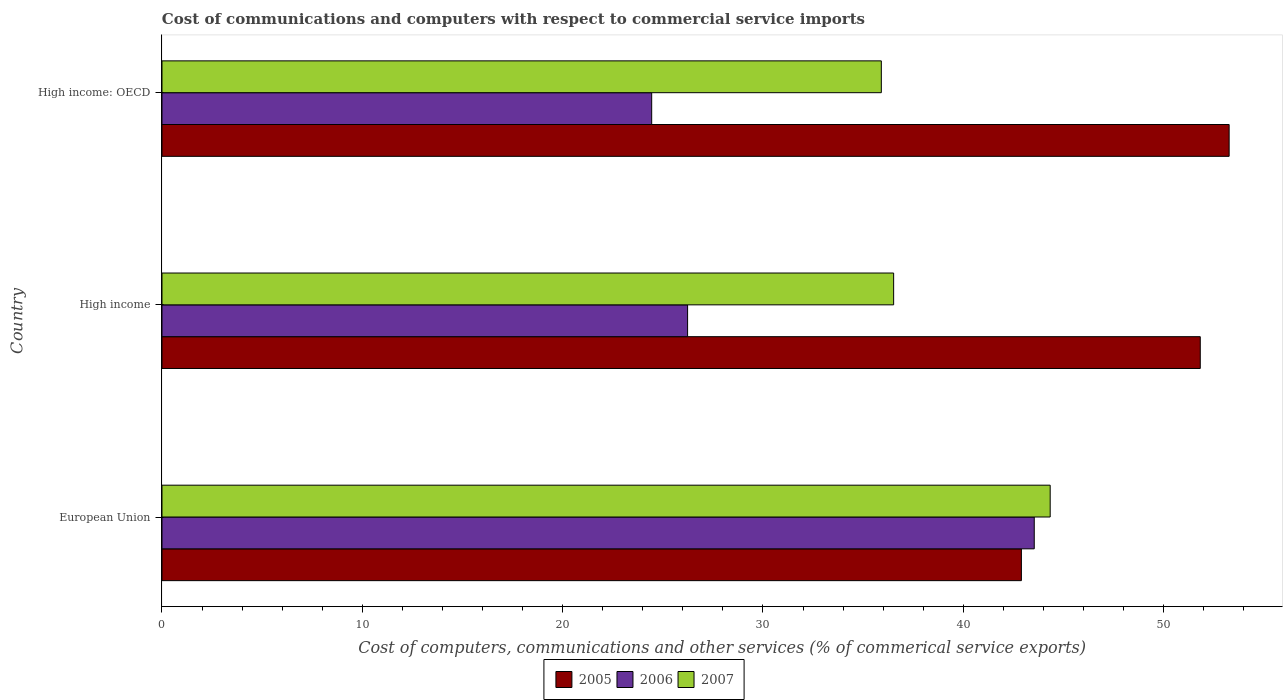How many different coloured bars are there?
Ensure brevity in your answer.  3. How many groups of bars are there?
Keep it short and to the point. 3. Are the number of bars on each tick of the Y-axis equal?
Ensure brevity in your answer.  Yes. What is the label of the 3rd group of bars from the top?
Offer a terse response. European Union. What is the cost of communications and computers in 2005 in European Union?
Offer a very short reply. 42.9. Across all countries, what is the maximum cost of communications and computers in 2007?
Your answer should be compact. 44.34. Across all countries, what is the minimum cost of communications and computers in 2005?
Your answer should be very brief. 42.9. In which country was the cost of communications and computers in 2005 minimum?
Provide a short and direct response. European Union. What is the total cost of communications and computers in 2007 in the graph?
Keep it short and to the point. 116.77. What is the difference between the cost of communications and computers in 2005 in European Union and that in High income?
Keep it short and to the point. -8.93. What is the difference between the cost of communications and computers in 2007 in European Union and the cost of communications and computers in 2005 in High income?
Give a very brief answer. -7.49. What is the average cost of communications and computers in 2006 per country?
Offer a terse response. 31.41. What is the difference between the cost of communications and computers in 2007 and cost of communications and computers in 2006 in High income: OECD?
Offer a terse response. 11.46. What is the ratio of the cost of communications and computers in 2005 in European Union to that in High income: OECD?
Offer a terse response. 0.81. What is the difference between the highest and the second highest cost of communications and computers in 2006?
Offer a terse response. 17.3. What is the difference between the highest and the lowest cost of communications and computers in 2006?
Your answer should be compact. 19.1. In how many countries, is the cost of communications and computers in 2005 greater than the average cost of communications and computers in 2005 taken over all countries?
Your response must be concise. 2. Is it the case that in every country, the sum of the cost of communications and computers in 2005 and cost of communications and computers in 2006 is greater than the cost of communications and computers in 2007?
Give a very brief answer. Yes. How many bars are there?
Your answer should be very brief. 9. How many countries are there in the graph?
Keep it short and to the point. 3. What is the difference between two consecutive major ticks on the X-axis?
Your answer should be compact. 10. Does the graph contain grids?
Make the answer very short. No. Where does the legend appear in the graph?
Provide a short and direct response. Bottom center. What is the title of the graph?
Provide a short and direct response. Cost of communications and computers with respect to commercial service imports. Does "1961" appear as one of the legend labels in the graph?
Provide a succinct answer. No. What is the label or title of the X-axis?
Your answer should be very brief. Cost of computers, communications and other services (% of commerical service exports). What is the Cost of computers, communications and other services (% of commerical service exports) in 2005 in European Union?
Offer a terse response. 42.9. What is the Cost of computers, communications and other services (% of commerical service exports) of 2006 in European Union?
Your answer should be compact. 43.54. What is the Cost of computers, communications and other services (% of commerical service exports) of 2007 in European Union?
Provide a succinct answer. 44.34. What is the Cost of computers, communications and other services (% of commerical service exports) of 2005 in High income?
Your response must be concise. 51.83. What is the Cost of computers, communications and other services (% of commerical service exports) in 2006 in High income?
Make the answer very short. 26.24. What is the Cost of computers, communications and other services (% of commerical service exports) in 2007 in High income?
Your answer should be very brief. 36.52. What is the Cost of computers, communications and other services (% of commerical service exports) of 2005 in High income: OECD?
Provide a short and direct response. 53.27. What is the Cost of computers, communications and other services (% of commerical service exports) in 2006 in High income: OECD?
Make the answer very short. 24.45. What is the Cost of computers, communications and other services (% of commerical service exports) of 2007 in High income: OECD?
Provide a short and direct response. 35.91. Across all countries, what is the maximum Cost of computers, communications and other services (% of commerical service exports) in 2005?
Give a very brief answer. 53.27. Across all countries, what is the maximum Cost of computers, communications and other services (% of commerical service exports) of 2006?
Provide a succinct answer. 43.54. Across all countries, what is the maximum Cost of computers, communications and other services (% of commerical service exports) in 2007?
Provide a short and direct response. 44.34. Across all countries, what is the minimum Cost of computers, communications and other services (% of commerical service exports) in 2005?
Give a very brief answer. 42.9. Across all countries, what is the minimum Cost of computers, communications and other services (% of commerical service exports) in 2006?
Provide a succinct answer. 24.45. Across all countries, what is the minimum Cost of computers, communications and other services (% of commerical service exports) of 2007?
Provide a succinct answer. 35.91. What is the total Cost of computers, communications and other services (% of commerical service exports) of 2005 in the graph?
Your response must be concise. 148. What is the total Cost of computers, communications and other services (% of commerical service exports) of 2006 in the graph?
Make the answer very short. 94.23. What is the total Cost of computers, communications and other services (% of commerical service exports) of 2007 in the graph?
Provide a succinct answer. 116.77. What is the difference between the Cost of computers, communications and other services (% of commerical service exports) of 2005 in European Union and that in High income?
Your answer should be compact. -8.93. What is the difference between the Cost of computers, communications and other services (% of commerical service exports) in 2006 in European Union and that in High income?
Your response must be concise. 17.3. What is the difference between the Cost of computers, communications and other services (% of commerical service exports) in 2007 in European Union and that in High income?
Provide a short and direct response. 7.81. What is the difference between the Cost of computers, communications and other services (% of commerical service exports) in 2005 in European Union and that in High income: OECD?
Give a very brief answer. -10.37. What is the difference between the Cost of computers, communications and other services (% of commerical service exports) of 2006 in European Union and that in High income: OECD?
Ensure brevity in your answer.  19.1. What is the difference between the Cost of computers, communications and other services (% of commerical service exports) of 2007 in European Union and that in High income: OECD?
Your answer should be very brief. 8.43. What is the difference between the Cost of computers, communications and other services (% of commerical service exports) in 2005 in High income and that in High income: OECD?
Provide a short and direct response. -1.44. What is the difference between the Cost of computers, communications and other services (% of commerical service exports) of 2006 in High income and that in High income: OECD?
Give a very brief answer. 1.79. What is the difference between the Cost of computers, communications and other services (% of commerical service exports) in 2007 in High income and that in High income: OECD?
Provide a short and direct response. 0.61. What is the difference between the Cost of computers, communications and other services (% of commerical service exports) of 2005 in European Union and the Cost of computers, communications and other services (% of commerical service exports) of 2006 in High income?
Your answer should be very brief. 16.66. What is the difference between the Cost of computers, communications and other services (% of commerical service exports) in 2005 in European Union and the Cost of computers, communications and other services (% of commerical service exports) in 2007 in High income?
Offer a very short reply. 6.38. What is the difference between the Cost of computers, communications and other services (% of commerical service exports) of 2006 in European Union and the Cost of computers, communications and other services (% of commerical service exports) of 2007 in High income?
Make the answer very short. 7.02. What is the difference between the Cost of computers, communications and other services (% of commerical service exports) of 2005 in European Union and the Cost of computers, communications and other services (% of commerical service exports) of 2006 in High income: OECD?
Your response must be concise. 18.46. What is the difference between the Cost of computers, communications and other services (% of commerical service exports) in 2005 in European Union and the Cost of computers, communications and other services (% of commerical service exports) in 2007 in High income: OECD?
Your response must be concise. 6.99. What is the difference between the Cost of computers, communications and other services (% of commerical service exports) of 2006 in European Union and the Cost of computers, communications and other services (% of commerical service exports) of 2007 in High income: OECD?
Your answer should be compact. 7.63. What is the difference between the Cost of computers, communications and other services (% of commerical service exports) of 2005 in High income and the Cost of computers, communications and other services (% of commerical service exports) of 2006 in High income: OECD?
Give a very brief answer. 27.38. What is the difference between the Cost of computers, communications and other services (% of commerical service exports) in 2005 in High income and the Cost of computers, communications and other services (% of commerical service exports) in 2007 in High income: OECD?
Make the answer very short. 15.92. What is the difference between the Cost of computers, communications and other services (% of commerical service exports) of 2006 in High income and the Cost of computers, communications and other services (% of commerical service exports) of 2007 in High income: OECD?
Offer a very short reply. -9.67. What is the average Cost of computers, communications and other services (% of commerical service exports) of 2005 per country?
Offer a very short reply. 49.33. What is the average Cost of computers, communications and other services (% of commerical service exports) in 2006 per country?
Offer a terse response. 31.41. What is the average Cost of computers, communications and other services (% of commerical service exports) of 2007 per country?
Your response must be concise. 38.92. What is the difference between the Cost of computers, communications and other services (% of commerical service exports) of 2005 and Cost of computers, communications and other services (% of commerical service exports) of 2006 in European Union?
Offer a very short reply. -0.64. What is the difference between the Cost of computers, communications and other services (% of commerical service exports) of 2005 and Cost of computers, communications and other services (% of commerical service exports) of 2007 in European Union?
Your answer should be compact. -1.44. What is the difference between the Cost of computers, communications and other services (% of commerical service exports) in 2006 and Cost of computers, communications and other services (% of commerical service exports) in 2007 in European Union?
Provide a succinct answer. -0.8. What is the difference between the Cost of computers, communications and other services (% of commerical service exports) in 2005 and Cost of computers, communications and other services (% of commerical service exports) in 2006 in High income?
Provide a succinct answer. 25.59. What is the difference between the Cost of computers, communications and other services (% of commerical service exports) in 2005 and Cost of computers, communications and other services (% of commerical service exports) in 2007 in High income?
Provide a short and direct response. 15.31. What is the difference between the Cost of computers, communications and other services (% of commerical service exports) of 2006 and Cost of computers, communications and other services (% of commerical service exports) of 2007 in High income?
Your answer should be compact. -10.29. What is the difference between the Cost of computers, communications and other services (% of commerical service exports) of 2005 and Cost of computers, communications and other services (% of commerical service exports) of 2006 in High income: OECD?
Your answer should be very brief. 28.83. What is the difference between the Cost of computers, communications and other services (% of commerical service exports) of 2005 and Cost of computers, communications and other services (% of commerical service exports) of 2007 in High income: OECD?
Provide a succinct answer. 17.36. What is the difference between the Cost of computers, communications and other services (% of commerical service exports) of 2006 and Cost of computers, communications and other services (% of commerical service exports) of 2007 in High income: OECD?
Offer a very short reply. -11.46. What is the ratio of the Cost of computers, communications and other services (% of commerical service exports) of 2005 in European Union to that in High income?
Make the answer very short. 0.83. What is the ratio of the Cost of computers, communications and other services (% of commerical service exports) of 2006 in European Union to that in High income?
Offer a terse response. 1.66. What is the ratio of the Cost of computers, communications and other services (% of commerical service exports) of 2007 in European Union to that in High income?
Offer a very short reply. 1.21. What is the ratio of the Cost of computers, communications and other services (% of commerical service exports) of 2005 in European Union to that in High income: OECD?
Offer a terse response. 0.81. What is the ratio of the Cost of computers, communications and other services (% of commerical service exports) in 2006 in European Union to that in High income: OECD?
Provide a succinct answer. 1.78. What is the ratio of the Cost of computers, communications and other services (% of commerical service exports) in 2007 in European Union to that in High income: OECD?
Keep it short and to the point. 1.23. What is the ratio of the Cost of computers, communications and other services (% of commerical service exports) in 2005 in High income to that in High income: OECD?
Provide a succinct answer. 0.97. What is the ratio of the Cost of computers, communications and other services (% of commerical service exports) of 2006 in High income to that in High income: OECD?
Offer a very short reply. 1.07. What is the ratio of the Cost of computers, communications and other services (% of commerical service exports) in 2007 in High income to that in High income: OECD?
Your response must be concise. 1.02. What is the difference between the highest and the second highest Cost of computers, communications and other services (% of commerical service exports) of 2005?
Offer a very short reply. 1.44. What is the difference between the highest and the second highest Cost of computers, communications and other services (% of commerical service exports) in 2006?
Your response must be concise. 17.3. What is the difference between the highest and the second highest Cost of computers, communications and other services (% of commerical service exports) in 2007?
Your answer should be compact. 7.81. What is the difference between the highest and the lowest Cost of computers, communications and other services (% of commerical service exports) of 2005?
Give a very brief answer. 10.37. What is the difference between the highest and the lowest Cost of computers, communications and other services (% of commerical service exports) in 2006?
Provide a succinct answer. 19.1. What is the difference between the highest and the lowest Cost of computers, communications and other services (% of commerical service exports) in 2007?
Keep it short and to the point. 8.43. 